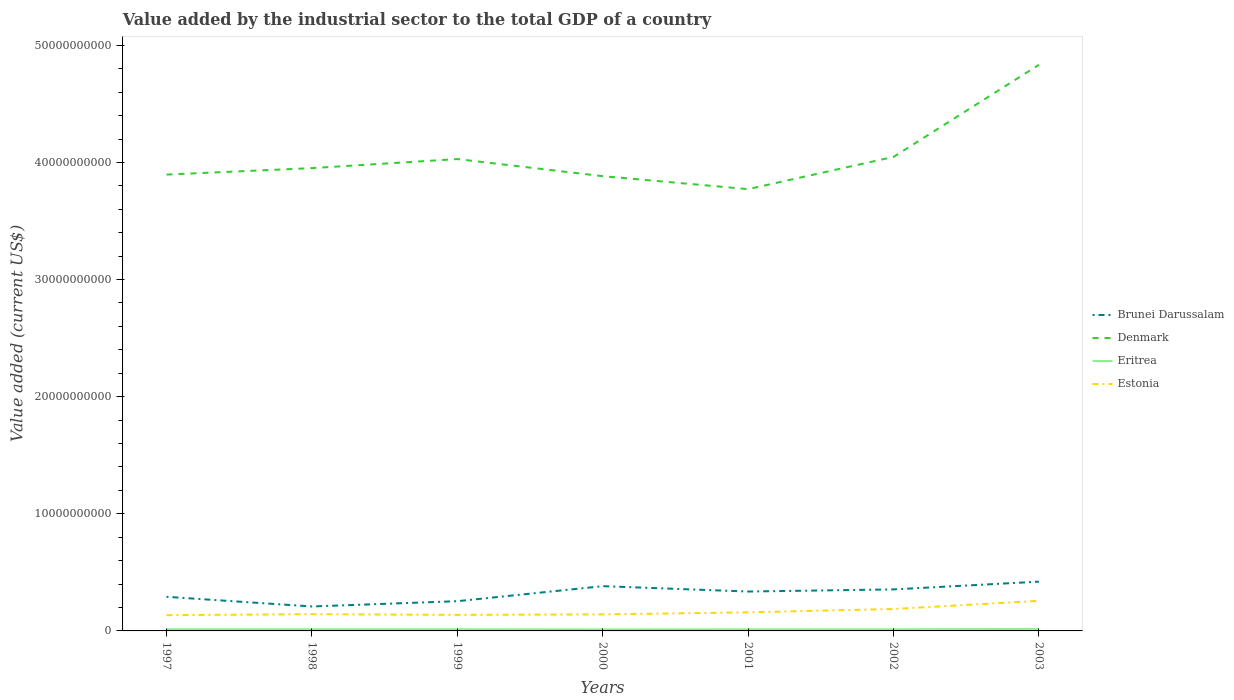Does the line corresponding to Eritrea intersect with the line corresponding to Denmark?
Ensure brevity in your answer.  No. Across all years, what is the maximum value added by the industrial sector to the total GDP in Denmark?
Make the answer very short. 3.77e+1. What is the total value added by the industrial sector to the total GDP in Brunei Darussalam in the graph?
Offer a very short reply. -9.08e+08. What is the difference between the highest and the second highest value added by the industrial sector to the total GDP in Denmark?
Provide a short and direct response. 1.06e+1. What is the difference between the highest and the lowest value added by the industrial sector to the total GDP in Estonia?
Provide a succinct answer. 2. Does the graph contain any zero values?
Provide a succinct answer. No. How many legend labels are there?
Your response must be concise. 4. How are the legend labels stacked?
Your answer should be very brief. Vertical. What is the title of the graph?
Your answer should be very brief. Value added by the industrial sector to the total GDP of a country. Does "Gabon" appear as one of the legend labels in the graph?
Provide a short and direct response. No. What is the label or title of the X-axis?
Offer a terse response. Years. What is the label or title of the Y-axis?
Offer a terse response. Value added (current US$). What is the Value added (current US$) of Brunei Darussalam in 1997?
Make the answer very short. 2.91e+09. What is the Value added (current US$) in Denmark in 1997?
Give a very brief answer. 3.90e+1. What is the Value added (current US$) of Eritrea in 1997?
Your response must be concise. 1.44e+08. What is the Value added (current US$) of Estonia in 1997?
Keep it short and to the point. 1.34e+09. What is the Value added (current US$) in Brunei Darussalam in 1998?
Your answer should be compact. 2.09e+09. What is the Value added (current US$) of Denmark in 1998?
Offer a terse response. 3.95e+1. What is the Value added (current US$) in Eritrea in 1998?
Make the answer very short. 1.44e+08. What is the Value added (current US$) of Estonia in 1998?
Your response must be concise. 1.43e+09. What is the Value added (current US$) of Brunei Darussalam in 1999?
Ensure brevity in your answer.  2.54e+09. What is the Value added (current US$) of Denmark in 1999?
Offer a very short reply. 4.03e+1. What is the Value added (current US$) of Eritrea in 1999?
Keep it short and to the point. 1.44e+08. What is the Value added (current US$) in Estonia in 1999?
Provide a short and direct response. 1.37e+09. What is the Value added (current US$) in Brunei Darussalam in 2000?
Keep it short and to the point. 3.82e+09. What is the Value added (current US$) of Denmark in 2000?
Your answer should be compact. 3.88e+1. What is the Value added (current US$) of Eritrea in 2000?
Your answer should be compact. 1.35e+08. What is the Value added (current US$) in Estonia in 2000?
Make the answer very short. 1.41e+09. What is the Value added (current US$) in Brunei Darussalam in 2001?
Ensure brevity in your answer.  3.36e+09. What is the Value added (current US$) in Denmark in 2001?
Provide a succinct answer. 3.77e+1. What is the Value added (current US$) of Eritrea in 2001?
Provide a succinct answer. 1.39e+08. What is the Value added (current US$) of Estonia in 2001?
Make the answer very short. 1.59e+09. What is the Value added (current US$) in Brunei Darussalam in 2002?
Provide a short and direct response. 3.54e+09. What is the Value added (current US$) in Denmark in 2002?
Make the answer very short. 4.05e+1. What is the Value added (current US$) of Eritrea in 2002?
Offer a terse response. 1.40e+08. What is the Value added (current US$) in Estonia in 2002?
Give a very brief answer. 1.87e+09. What is the Value added (current US$) in Brunei Darussalam in 2003?
Provide a short and direct response. 4.21e+09. What is the Value added (current US$) in Denmark in 2003?
Your answer should be compact. 4.83e+1. What is the Value added (current US$) of Eritrea in 2003?
Make the answer very short. 1.71e+08. What is the Value added (current US$) in Estonia in 2003?
Provide a succinct answer. 2.57e+09. Across all years, what is the maximum Value added (current US$) in Brunei Darussalam?
Your answer should be very brief. 4.21e+09. Across all years, what is the maximum Value added (current US$) of Denmark?
Make the answer very short. 4.83e+1. Across all years, what is the maximum Value added (current US$) of Eritrea?
Make the answer very short. 1.71e+08. Across all years, what is the maximum Value added (current US$) in Estonia?
Your response must be concise. 2.57e+09. Across all years, what is the minimum Value added (current US$) of Brunei Darussalam?
Give a very brief answer. 2.09e+09. Across all years, what is the minimum Value added (current US$) in Denmark?
Provide a succinct answer. 3.77e+1. Across all years, what is the minimum Value added (current US$) of Eritrea?
Make the answer very short. 1.35e+08. Across all years, what is the minimum Value added (current US$) of Estonia?
Provide a short and direct response. 1.34e+09. What is the total Value added (current US$) in Brunei Darussalam in the graph?
Give a very brief answer. 2.25e+1. What is the total Value added (current US$) in Denmark in the graph?
Ensure brevity in your answer.  2.84e+11. What is the total Value added (current US$) of Eritrea in the graph?
Give a very brief answer. 1.02e+09. What is the total Value added (current US$) in Estonia in the graph?
Provide a short and direct response. 1.16e+1. What is the difference between the Value added (current US$) of Brunei Darussalam in 1997 and that in 1998?
Give a very brief answer. 8.25e+08. What is the difference between the Value added (current US$) of Denmark in 1997 and that in 1998?
Keep it short and to the point. -5.51e+08. What is the difference between the Value added (current US$) of Eritrea in 1997 and that in 1998?
Your response must be concise. 2.91e+05. What is the difference between the Value added (current US$) of Estonia in 1997 and that in 1998?
Provide a succinct answer. -8.52e+07. What is the difference between the Value added (current US$) of Brunei Darussalam in 1997 and that in 1999?
Ensure brevity in your answer.  3.74e+08. What is the difference between the Value added (current US$) in Denmark in 1997 and that in 1999?
Keep it short and to the point. -1.32e+09. What is the difference between the Value added (current US$) of Eritrea in 1997 and that in 1999?
Make the answer very short. 2.24e+05. What is the difference between the Value added (current US$) of Estonia in 1997 and that in 1999?
Keep it short and to the point. -2.50e+07. What is the difference between the Value added (current US$) in Brunei Darussalam in 1997 and that in 2000?
Offer a very short reply. -9.08e+08. What is the difference between the Value added (current US$) in Denmark in 1997 and that in 2000?
Your answer should be very brief. 1.36e+08. What is the difference between the Value added (current US$) in Eritrea in 1997 and that in 2000?
Give a very brief answer. 8.69e+06. What is the difference between the Value added (current US$) of Estonia in 1997 and that in 2000?
Ensure brevity in your answer.  -6.87e+07. What is the difference between the Value added (current US$) in Brunei Darussalam in 1997 and that in 2001?
Your answer should be very brief. -4.50e+08. What is the difference between the Value added (current US$) of Denmark in 1997 and that in 2001?
Your response must be concise. 1.24e+09. What is the difference between the Value added (current US$) of Eritrea in 1997 and that in 2001?
Make the answer very short. 4.59e+06. What is the difference between the Value added (current US$) of Estonia in 1997 and that in 2001?
Make the answer very short. -2.42e+08. What is the difference between the Value added (current US$) of Brunei Darussalam in 1997 and that in 2002?
Your response must be concise. -6.32e+08. What is the difference between the Value added (current US$) of Denmark in 1997 and that in 2002?
Ensure brevity in your answer.  -1.51e+09. What is the difference between the Value added (current US$) of Eritrea in 1997 and that in 2002?
Your answer should be compact. 4.19e+06. What is the difference between the Value added (current US$) of Estonia in 1997 and that in 2002?
Your response must be concise. -5.27e+08. What is the difference between the Value added (current US$) in Brunei Darussalam in 1997 and that in 2003?
Keep it short and to the point. -1.29e+09. What is the difference between the Value added (current US$) in Denmark in 1997 and that in 2003?
Provide a succinct answer. -9.37e+09. What is the difference between the Value added (current US$) in Eritrea in 1997 and that in 2003?
Keep it short and to the point. -2.74e+07. What is the difference between the Value added (current US$) of Estonia in 1997 and that in 2003?
Offer a very short reply. -1.23e+09. What is the difference between the Value added (current US$) of Brunei Darussalam in 1998 and that in 1999?
Your answer should be compact. -4.51e+08. What is the difference between the Value added (current US$) in Denmark in 1998 and that in 1999?
Your answer should be compact. -7.73e+08. What is the difference between the Value added (current US$) of Eritrea in 1998 and that in 1999?
Make the answer very short. -6.68e+04. What is the difference between the Value added (current US$) in Estonia in 1998 and that in 1999?
Provide a short and direct response. 6.02e+07. What is the difference between the Value added (current US$) in Brunei Darussalam in 1998 and that in 2000?
Provide a succinct answer. -1.73e+09. What is the difference between the Value added (current US$) of Denmark in 1998 and that in 2000?
Offer a very short reply. 6.87e+08. What is the difference between the Value added (current US$) in Eritrea in 1998 and that in 2000?
Make the answer very short. 8.39e+06. What is the difference between the Value added (current US$) of Estonia in 1998 and that in 2000?
Your response must be concise. 1.65e+07. What is the difference between the Value added (current US$) of Brunei Darussalam in 1998 and that in 2001?
Your response must be concise. -1.28e+09. What is the difference between the Value added (current US$) in Denmark in 1998 and that in 2001?
Your response must be concise. 1.79e+09. What is the difference between the Value added (current US$) of Eritrea in 1998 and that in 2001?
Your response must be concise. 4.30e+06. What is the difference between the Value added (current US$) in Estonia in 1998 and that in 2001?
Keep it short and to the point. -1.57e+08. What is the difference between the Value added (current US$) in Brunei Darussalam in 1998 and that in 2002?
Offer a terse response. -1.46e+09. What is the difference between the Value added (current US$) in Denmark in 1998 and that in 2002?
Your answer should be compact. -9.56e+08. What is the difference between the Value added (current US$) in Eritrea in 1998 and that in 2002?
Offer a very short reply. 3.90e+06. What is the difference between the Value added (current US$) of Estonia in 1998 and that in 2002?
Provide a short and direct response. -4.42e+08. What is the difference between the Value added (current US$) of Brunei Darussalam in 1998 and that in 2003?
Provide a short and direct response. -2.12e+09. What is the difference between the Value added (current US$) in Denmark in 1998 and that in 2003?
Keep it short and to the point. -8.82e+09. What is the difference between the Value added (current US$) of Eritrea in 1998 and that in 2003?
Offer a terse response. -2.77e+07. What is the difference between the Value added (current US$) of Estonia in 1998 and that in 2003?
Provide a succinct answer. -1.14e+09. What is the difference between the Value added (current US$) in Brunei Darussalam in 1999 and that in 2000?
Ensure brevity in your answer.  -1.28e+09. What is the difference between the Value added (current US$) in Denmark in 1999 and that in 2000?
Provide a short and direct response. 1.46e+09. What is the difference between the Value added (current US$) in Eritrea in 1999 and that in 2000?
Offer a very short reply. 8.46e+06. What is the difference between the Value added (current US$) of Estonia in 1999 and that in 2000?
Make the answer very short. -4.37e+07. What is the difference between the Value added (current US$) of Brunei Darussalam in 1999 and that in 2001?
Provide a short and direct response. -8.25e+08. What is the difference between the Value added (current US$) in Denmark in 1999 and that in 2001?
Your answer should be compact. 2.57e+09. What is the difference between the Value added (current US$) in Eritrea in 1999 and that in 2001?
Give a very brief answer. 4.37e+06. What is the difference between the Value added (current US$) of Estonia in 1999 and that in 2001?
Give a very brief answer. -2.17e+08. What is the difference between the Value added (current US$) of Brunei Darussalam in 1999 and that in 2002?
Give a very brief answer. -1.01e+09. What is the difference between the Value added (current US$) in Denmark in 1999 and that in 2002?
Your answer should be very brief. -1.83e+08. What is the difference between the Value added (current US$) of Eritrea in 1999 and that in 2002?
Offer a terse response. 3.97e+06. What is the difference between the Value added (current US$) in Estonia in 1999 and that in 2002?
Offer a terse response. -5.02e+08. What is the difference between the Value added (current US$) of Brunei Darussalam in 1999 and that in 2003?
Offer a very short reply. -1.67e+09. What is the difference between the Value added (current US$) in Denmark in 1999 and that in 2003?
Keep it short and to the point. -8.05e+09. What is the difference between the Value added (current US$) in Eritrea in 1999 and that in 2003?
Your answer should be compact. -2.76e+07. What is the difference between the Value added (current US$) of Estonia in 1999 and that in 2003?
Provide a succinct answer. -1.20e+09. What is the difference between the Value added (current US$) of Brunei Darussalam in 2000 and that in 2001?
Make the answer very short. 4.58e+08. What is the difference between the Value added (current US$) of Denmark in 2000 and that in 2001?
Your answer should be very brief. 1.11e+09. What is the difference between the Value added (current US$) in Eritrea in 2000 and that in 2001?
Your answer should be very brief. -4.09e+06. What is the difference between the Value added (current US$) in Estonia in 2000 and that in 2001?
Make the answer very short. -1.74e+08. What is the difference between the Value added (current US$) in Brunei Darussalam in 2000 and that in 2002?
Your answer should be compact. 2.76e+08. What is the difference between the Value added (current US$) in Denmark in 2000 and that in 2002?
Offer a terse response. -1.64e+09. What is the difference between the Value added (current US$) in Eritrea in 2000 and that in 2002?
Your response must be concise. -4.49e+06. What is the difference between the Value added (current US$) in Estonia in 2000 and that in 2002?
Keep it short and to the point. -4.59e+08. What is the difference between the Value added (current US$) in Brunei Darussalam in 2000 and that in 2003?
Offer a terse response. -3.85e+08. What is the difference between the Value added (current US$) of Denmark in 2000 and that in 2003?
Ensure brevity in your answer.  -9.51e+09. What is the difference between the Value added (current US$) in Eritrea in 2000 and that in 2003?
Your answer should be very brief. -3.61e+07. What is the difference between the Value added (current US$) of Estonia in 2000 and that in 2003?
Offer a terse response. -1.16e+09. What is the difference between the Value added (current US$) in Brunei Darussalam in 2001 and that in 2002?
Your response must be concise. -1.82e+08. What is the difference between the Value added (current US$) in Denmark in 2001 and that in 2002?
Make the answer very short. -2.75e+09. What is the difference between the Value added (current US$) in Eritrea in 2001 and that in 2002?
Offer a terse response. -3.99e+05. What is the difference between the Value added (current US$) of Estonia in 2001 and that in 2002?
Keep it short and to the point. -2.85e+08. What is the difference between the Value added (current US$) in Brunei Darussalam in 2001 and that in 2003?
Keep it short and to the point. -8.43e+08. What is the difference between the Value added (current US$) in Denmark in 2001 and that in 2003?
Give a very brief answer. -1.06e+1. What is the difference between the Value added (current US$) in Eritrea in 2001 and that in 2003?
Your answer should be very brief. -3.20e+07. What is the difference between the Value added (current US$) in Estonia in 2001 and that in 2003?
Your answer should be very brief. -9.84e+08. What is the difference between the Value added (current US$) of Brunei Darussalam in 2002 and that in 2003?
Provide a succinct answer. -6.62e+08. What is the difference between the Value added (current US$) of Denmark in 2002 and that in 2003?
Keep it short and to the point. -7.87e+09. What is the difference between the Value added (current US$) in Eritrea in 2002 and that in 2003?
Your response must be concise. -3.16e+07. What is the difference between the Value added (current US$) in Estonia in 2002 and that in 2003?
Make the answer very short. -6.99e+08. What is the difference between the Value added (current US$) of Brunei Darussalam in 1997 and the Value added (current US$) of Denmark in 1998?
Give a very brief answer. -3.66e+1. What is the difference between the Value added (current US$) of Brunei Darussalam in 1997 and the Value added (current US$) of Eritrea in 1998?
Offer a terse response. 2.77e+09. What is the difference between the Value added (current US$) of Brunei Darussalam in 1997 and the Value added (current US$) of Estonia in 1998?
Offer a terse response. 1.48e+09. What is the difference between the Value added (current US$) in Denmark in 1997 and the Value added (current US$) in Eritrea in 1998?
Provide a short and direct response. 3.88e+1. What is the difference between the Value added (current US$) in Denmark in 1997 and the Value added (current US$) in Estonia in 1998?
Ensure brevity in your answer.  3.75e+1. What is the difference between the Value added (current US$) in Eritrea in 1997 and the Value added (current US$) in Estonia in 1998?
Offer a terse response. -1.28e+09. What is the difference between the Value added (current US$) in Brunei Darussalam in 1997 and the Value added (current US$) in Denmark in 1999?
Ensure brevity in your answer.  -3.74e+1. What is the difference between the Value added (current US$) of Brunei Darussalam in 1997 and the Value added (current US$) of Eritrea in 1999?
Ensure brevity in your answer.  2.77e+09. What is the difference between the Value added (current US$) in Brunei Darussalam in 1997 and the Value added (current US$) in Estonia in 1999?
Provide a succinct answer. 1.54e+09. What is the difference between the Value added (current US$) of Denmark in 1997 and the Value added (current US$) of Eritrea in 1999?
Ensure brevity in your answer.  3.88e+1. What is the difference between the Value added (current US$) of Denmark in 1997 and the Value added (current US$) of Estonia in 1999?
Offer a very short reply. 3.76e+1. What is the difference between the Value added (current US$) in Eritrea in 1997 and the Value added (current US$) in Estonia in 1999?
Offer a terse response. -1.22e+09. What is the difference between the Value added (current US$) of Brunei Darussalam in 1997 and the Value added (current US$) of Denmark in 2000?
Provide a short and direct response. -3.59e+1. What is the difference between the Value added (current US$) in Brunei Darussalam in 1997 and the Value added (current US$) in Eritrea in 2000?
Your answer should be compact. 2.78e+09. What is the difference between the Value added (current US$) of Brunei Darussalam in 1997 and the Value added (current US$) of Estonia in 2000?
Offer a terse response. 1.50e+09. What is the difference between the Value added (current US$) of Denmark in 1997 and the Value added (current US$) of Eritrea in 2000?
Make the answer very short. 3.88e+1. What is the difference between the Value added (current US$) in Denmark in 1997 and the Value added (current US$) in Estonia in 2000?
Keep it short and to the point. 3.76e+1. What is the difference between the Value added (current US$) of Eritrea in 1997 and the Value added (current US$) of Estonia in 2000?
Provide a succinct answer. -1.27e+09. What is the difference between the Value added (current US$) in Brunei Darussalam in 1997 and the Value added (current US$) in Denmark in 2001?
Your response must be concise. -3.48e+1. What is the difference between the Value added (current US$) of Brunei Darussalam in 1997 and the Value added (current US$) of Eritrea in 2001?
Offer a terse response. 2.77e+09. What is the difference between the Value added (current US$) of Brunei Darussalam in 1997 and the Value added (current US$) of Estonia in 2001?
Your response must be concise. 1.33e+09. What is the difference between the Value added (current US$) in Denmark in 1997 and the Value added (current US$) in Eritrea in 2001?
Your answer should be compact. 3.88e+1. What is the difference between the Value added (current US$) in Denmark in 1997 and the Value added (current US$) in Estonia in 2001?
Give a very brief answer. 3.74e+1. What is the difference between the Value added (current US$) of Eritrea in 1997 and the Value added (current US$) of Estonia in 2001?
Offer a terse response. -1.44e+09. What is the difference between the Value added (current US$) in Brunei Darussalam in 1997 and the Value added (current US$) in Denmark in 2002?
Your response must be concise. -3.76e+1. What is the difference between the Value added (current US$) in Brunei Darussalam in 1997 and the Value added (current US$) in Eritrea in 2002?
Your answer should be very brief. 2.77e+09. What is the difference between the Value added (current US$) of Brunei Darussalam in 1997 and the Value added (current US$) of Estonia in 2002?
Offer a terse response. 1.04e+09. What is the difference between the Value added (current US$) in Denmark in 1997 and the Value added (current US$) in Eritrea in 2002?
Offer a very short reply. 3.88e+1. What is the difference between the Value added (current US$) of Denmark in 1997 and the Value added (current US$) of Estonia in 2002?
Your answer should be compact. 3.71e+1. What is the difference between the Value added (current US$) of Eritrea in 1997 and the Value added (current US$) of Estonia in 2002?
Your answer should be very brief. -1.73e+09. What is the difference between the Value added (current US$) of Brunei Darussalam in 1997 and the Value added (current US$) of Denmark in 2003?
Offer a terse response. -4.54e+1. What is the difference between the Value added (current US$) in Brunei Darussalam in 1997 and the Value added (current US$) in Eritrea in 2003?
Give a very brief answer. 2.74e+09. What is the difference between the Value added (current US$) of Brunei Darussalam in 1997 and the Value added (current US$) of Estonia in 2003?
Offer a very short reply. 3.43e+08. What is the difference between the Value added (current US$) in Denmark in 1997 and the Value added (current US$) in Eritrea in 2003?
Provide a succinct answer. 3.88e+1. What is the difference between the Value added (current US$) of Denmark in 1997 and the Value added (current US$) of Estonia in 2003?
Give a very brief answer. 3.64e+1. What is the difference between the Value added (current US$) of Eritrea in 1997 and the Value added (current US$) of Estonia in 2003?
Ensure brevity in your answer.  -2.43e+09. What is the difference between the Value added (current US$) in Brunei Darussalam in 1998 and the Value added (current US$) in Denmark in 1999?
Offer a very short reply. -3.82e+1. What is the difference between the Value added (current US$) of Brunei Darussalam in 1998 and the Value added (current US$) of Eritrea in 1999?
Your answer should be very brief. 1.94e+09. What is the difference between the Value added (current US$) of Brunei Darussalam in 1998 and the Value added (current US$) of Estonia in 1999?
Keep it short and to the point. 7.19e+08. What is the difference between the Value added (current US$) of Denmark in 1998 and the Value added (current US$) of Eritrea in 1999?
Give a very brief answer. 3.94e+1. What is the difference between the Value added (current US$) of Denmark in 1998 and the Value added (current US$) of Estonia in 1999?
Make the answer very short. 3.81e+1. What is the difference between the Value added (current US$) of Eritrea in 1998 and the Value added (current US$) of Estonia in 1999?
Provide a succinct answer. -1.22e+09. What is the difference between the Value added (current US$) of Brunei Darussalam in 1998 and the Value added (current US$) of Denmark in 2000?
Provide a succinct answer. -3.67e+1. What is the difference between the Value added (current US$) in Brunei Darussalam in 1998 and the Value added (current US$) in Eritrea in 2000?
Your answer should be compact. 1.95e+09. What is the difference between the Value added (current US$) in Brunei Darussalam in 1998 and the Value added (current US$) in Estonia in 2000?
Ensure brevity in your answer.  6.75e+08. What is the difference between the Value added (current US$) in Denmark in 1998 and the Value added (current US$) in Eritrea in 2000?
Provide a succinct answer. 3.94e+1. What is the difference between the Value added (current US$) in Denmark in 1998 and the Value added (current US$) in Estonia in 2000?
Keep it short and to the point. 3.81e+1. What is the difference between the Value added (current US$) in Eritrea in 1998 and the Value added (current US$) in Estonia in 2000?
Ensure brevity in your answer.  -1.27e+09. What is the difference between the Value added (current US$) in Brunei Darussalam in 1998 and the Value added (current US$) in Denmark in 2001?
Your answer should be very brief. -3.56e+1. What is the difference between the Value added (current US$) of Brunei Darussalam in 1998 and the Value added (current US$) of Eritrea in 2001?
Keep it short and to the point. 1.95e+09. What is the difference between the Value added (current US$) of Brunei Darussalam in 1998 and the Value added (current US$) of Estonia in 2001?
Offer a terse response. 5.02e+08. What is the difference between the Value added (current US$) of Denmark in 1998 and the Value added (current US$) of Eritrea in 2001?
Offer a terse response. 3.94e+1. What is the difference between the Value added (current US$) of Denmark in 1998 and the Value added (current US$) of Estonia in 2001?
Offer a very short reply. 3.79e+1. What is the difference between the Value added (current US$) in Eritrea in 1998 and the Value added (current US$) in Estonia in 2001?
Make the answer very short. -1.44e+09. What is the difference between the Value added (current US$) in Brunei Darussalam in 1998 and the Value added (current US$) in Denmark in 2002?
Keep it short and to the point. -3.84e+1. What is the difference between the Value added (current US$) in Brunei Darussalam in 1998 and the Value added (current US$) in Eritrea in 2002?
Give a very brief answer. 1.95e+09. What is the difference between the Value added (current US$) of Brunei Darussalam in 1998 and the Value added (current US$) of Estonia in 2002?
Give a very brief answer. 2.17e+08. What is the difference between the Value added (current US$) of Denmark in 1998 and the Value added (current US$) of Eritrea in 2002?
Give a very brief answer. 3.94e+1. What is the difference between the Value added (current US$) of Denmark in 1998 and the Value added (current US$) of Estonia in 2002?
Give a very brief answer. 3.76e+1. What is the difference between the Value added (current US$) in Eritrea in 1998 and the Value added (current US$) in Estonia in 2002?
Make the answer very short. -1.73e+09. What is the difference between the Value added (current US$) in Brunei Darussalam in 1998 and the Value added (current US$) in Denmark in 2003?
Give a very brief answer. -4.62e+1. What is the difference between the Value added (current US$) of Brunei Darussalam in 1998 and the Value added (current US$) of Eritrea in 2003?
Your answer should be very brief. 1.92e+09. What is the difference between the Value added (current US$) in Brunei Darussalam in 1998 and the Value added (current US$) in Estonia in 2003?
Your answer should be compact. -4.82e+08. What is the difference between the Value added (current US$) in Denmark in 1998 and the Value added (current US$) in Eritrea in 2003?
Give a very brief answer. 3.93e+1. What is the difference between the Value added (current US$) of Denmark in 1998 and the Value added (current US$) of Estonia in 2003?
Your answer should be compact. 3.69e+1. What is the difference between the Value added (current US$) in Eritrea in 1998 and the Value added (current US$) in Estonia in 2003?
Your answer should be very brief. -2.43e+09. What is the difference between the Value added (current US$) in Brunei Darussalam in 1999 and the Value added (current US$) in Denmark in 2000?
Provide a succinct answer. -3.63e+1. What is the difference between the Value added (current US$) in Brunei Darussalam in 1999 and the Value added (current US$) in Eritrea in 2000?
Your answer should be very brief. 2.40e+09. What is the difference between the Value added (current US$) of Brunei Darussalam in 1999 and the Value added (current US$) of Estonia in 2000?
Offer a terse response. 1.13e+09. What is the difference between the Value added (current US$) of Denmark in 1999 and the Value added (current US$) of Eritrea in 2000?
Give a very brief answer. 4.02e+1. What is the difference between the Value added (current US$) in Denmark in 1999 and the Value added (current US$) in Estonia in 2000?
Your answer should be very brief. 3.89e+1. What is the difference between the Value added (current US$) of Eritrea in 1999 and the Value added (current US$) of Estonia in 2000?
Ensure brevity in your answer.  -1.27e+09. What is the difference between the Value added (current US$) of Brunei Darussalam in 1999 and the Value added (current US$) of Denmark in 2001?
Provide a short and direct response. -3.52e+1. What is the difference between the Value added (current US$) of Brunei Darussalam in 1999 and the Value added (current US$) of Eritrea in 2001?
Your answer should be very brief. 2.40e+09. What is the difference between the Value added (current US$) in Brunei Darussalam in 1999 and the Value added (current US$) in Estonia in 2001?
Offer a terse response. 9.53e+08. What is the difference between the Value added (current US$) in Denmark in 1999 and the Value added (current US$) in Eritrea in 2001?
Your answer should be very brief. 4.01e+1. What is the difference between the Value added (current US$) of Denmark in 1999 and the Value added (current US$) of Estonia in 2001?
Offer a terse response. 3.87e+1. What is the difference between the Value added (current US$) in Eritrea in 1999 and the Value added (current US$) in Estonia in 2001?
Your answer should be compact. -1.44e+09. What is the difference between the Value added (current US$) of Brunei Darussalam in 1999 and the Value added (current US$) of Denmark in 2002?
Your answer should be very brief. -3.79e+1. What is the difference between the Value added (current US$) in Brunei Darussalam in 1999 and the Value added (current US$) in Eritrea in 2002?
Offer a very short reply. 2.40e+09. What is the difference between the Value added (current US$) of Brunei Darussalam in 1999 and the Value added (current US$) of Estonia in 2002?
Make the answer very short. 6.67e+08. What is the difference between the Value added (current US$) of Denmark in 1999 and the Value added (current US$) of Eritrea in 2002?
Your answer should be compact. 4.01e+1. What is the difference between the Value added (current US$) in Denmark in 1999 and the Value added (current US$) in Estonia in 2002?
Offer a terse response. 3.84e+1. What is the difference between the Value added (current US$) in Eritrea in 1999 and the Value added (current US$) in Estonia in 2002?
Provide a succinct answer. -1.73e+09. What is the difference between the Value added (current US$) in Brunei Darussalam in 1999 and the Value added (current US$) in Denmark in 2003?
Offer a very short reply. -4.58e+1. What is the difference between the Value added (current US$) of Brunei Darussalam in 1999 and the Value added (current US$) of Eritrea in 2003?
Keep it short and to the point. 2.37e+09. What is the difference between the Value added (current US$) in Brunei Darussalam in 1999 and the Value added (current US$) in Estonia in 2003?
Offer a very short reply. -3.13e+07. What is the difference between the Value added (current US$) of Denmark in 1999 and the Value added (current US$) of Eritrea in 2003?
Make the answer very short. 4.01e+1. What is the difference between the Value added (current US$) in Denmark in 1999 and the Value added (current US$) in Estonia in 2003?
Your response must be concise. 3.77e+1. What is the difference between the Value added (current US$) of Eritrea in 1999 and the Value added (current US$) of Estonia in 2003?
Offer a terse response. -2.43e+09. What is the difference between the Value added (current US$) of Brunei Darussalam in 2000 and the Value added (current US$) of Denmark in 2001?
Your response must be concise. -3.39e+1. What is the difference between the Value added (current US$) in Brunei Darussalam in 2000 and the Value added (current US$) in Eritrea in 2001?
Give a very brief answer. 3.68e+09. What is the difference between the Value added (current US$) in Brunei Darussalam in 2000 and the Value added (current US$) in Estonia in 2001?
Give a very brief answer. 2.24e+09. What is the difference between the Value added (current US$) of Denmark in 2000 and the Value added (current US$) of Eritrea in 2001?
Your answer should be very brief. 3.87e+1. What is the difference between the Value added (current US$) in Denmark in 2000 and the Value added (current US$) in Estonia in 2001?
Offer a terse response. 3.72e+1. What is the difference between the Value added (current US$) in Eritrea in 2000 and the Value added (current US$) in Estonia in 2001?
Provide a succinct answer. -1.45e+09. What is the difference between the Value added (current US$) in Brunei Darussalam in 2000 and the Value added (current US$) in Denmark in 2002?
Make the answer very short. -3.67e+1. What is the difference between the Value added (current US$) of Brunei Darussalam in 2000 and the Value added (current US$) of Eritrea in 2002?
Offer a terse response. 3.68e+09. What is the difference between the Value added (current US$) of Brunei Darussalam in 2000 and the Value added (current US$) of Estonia in 2002?
Your answer should be compact. 1.95e+09. What is the difference between the Value added (current US$) in Denmark in 2000 and the Value added (current US$) in Eritrea in 2002?
Your answer should be compact. 3.87e+1. What is the difference between the Value added (current US$) in Denmark in 2000 and the Value added (current US$) in Estonia in 2002?
Ensure brevity in your answer.  3.70e+1. What is the difference between the Value added (current US$) of Eritrea in 2000 and the Value added (current US$) of Estonia in 2002?
Offer a terse response. -1.74e+09. What is the difference between the Value added (current US$) in Brunei Darussalam in 2000 and the Value added (current US$) in Denmark in 2003?
Provide a succinct answer. -4.45e+1. What is the difference between the Value added (current US$) in Brunei Darussalam in 2000 and the Value added (current US$) in Eritrea in 2003?
Give a very brief answer. 3.65e+09. What is the difference between the Value added (current US$) in Brunei Darussalam in 2000 and the Value added (current US$) in Estonia in 2003?
Your answer should be compact. 1.25e+09. What is the difference between the Value added (current US$) in Denmark in 2000 and the Value added (current US$) in Eritrea in 2003?
Provide a succinct answer. 3.87e+1. What is the difference between the Value added (current US$) of Denmark in 2000 and the Value added (current US$) of Estonia in 2003?
Provide a succinct answer. 3.63e+1. What is the difference between the Value added (current US$) in Eritrea in 2000 and the Value added (current US$) in Estonia in 2003?
Offer a very short reply. -2.43e+09. What is the difference between the Value added (current US$) in Brunei Darussalam in 2001 and the Value added (current US$) in Denmark in 2002?
Give a very brief answer. -3.71e+1. What is the difference between the Value added (current US$) in Brunei Darussalam in 2001 and the Value added (current US$) in Eritrea in 2002?
Ensure brevity in your answer.  3.22e+09. What is the difference between the Value added (current US$) of Brunei Darussalam in 2001 and the Value added (current US$) of Estonia in 2002?
Provide a succinct answer. 1.49e+09. What is the difference between the Value added (current US$) in Denmark in 2001 and the Value added (current US$) in Eritrea in 2002?
Offer a terse response. 3.76e+1. What is the difference between the Value added (current US$) in Denmark in 2001 and the Value added (current US$) in Estonia in 2002?
Your answer should be very brief. 3.59e+1. What is the difference between the Value added (current US$) in Eritrea in 2001 and the Value added (current US$) in Estonia in 2002?
Your response must be concise. -1.73e+09. What is the difference between the Value added (current US$) in Brunei Darussalam in 2001 and the Value added (current US$) in Denmark in 2003?
Provide a short and direct response. -4.50e+1. What is the difference between the Value added (current US$) in Brunei Darussalam in 2001 and the Value added (current US$) in Eritrea in 2003?
Offer a very short reply. 3.19e+09. What is the difference between the Value added (current US$) in Brunei Darussalam in 2001 and the Value added (current US$) in Estonia in 2003?
Your response must be concise. 7.93e+08. What is the difference between the Value added (current US$) of Denmark in 2001 and the Value added (current US$) of Eritrea in 2003?
Provide a succinct answer. 3.76e+1. What is the difference between the Value added (current US$) in Denmark in 2001 and the Value added (current US$) in Estonia in 2003?
Ensure brevity in your answer.  3.52e+1. What is the difference between the Value added (current US$) of Eritrea in 2001 and the Value added (current US$) of Estonia in 2003?
Give a very brief answer. -2.43e+09. What is the difference between the Value added (current US$) of Brunei Darussalam in 2002 and the Value added (current US$) of Denmark in 2003?
Provide a short and direct response. -4.48e+1. What is the difference between the Value added (current US$) in Brunei Darussalam in 2002 and the Value added (current US$) in Eritrea in 2003?
Your answer should be very brief. 3.37e+09. What is the difference between the Value added (current US$) in Brunei Darussalam in 2002 and the Value added (current US$) in Estonia in 2003?
Provide a succinct answer. 9.75e+08. What is the difference between the Value added (current US$) in Denmark in 2002 and the Value added (current US$) in Eritrea in 2003?
Your answer should be compact. 4.03e+1. What is the difference between the Value added (current US$) of Denmark in 2002 and the Value added (current US$) of Estonia in 2003?
Give a very brief answer. 3.79e+1. What is the difference between the Value added (current US$) of Eritrea in 2002 and the Value added (current US$) of Estonia in 2003?
Provide a short and direct response. -2.43e+09. What is the average Value added (current US$) in Brunei Darussalam per year?
Keep it short and to the point. 3.21e+09. What is the average Value added (current US$) in Denmark per year?
Make the answer very short. 4.06e+1. What is the average Value added (current US$) in Eritrea per year?
Your response must be concise. 1.45e+08. What is the average Value added (current US$) of Estonia per year?
Your answer should be very brief. 1.65e+09. In the year 1997, what is the difference between the Value added (current US$) of Brunei Darussalam and Value added (current US$) of Denmark?
Your answer should be very brief. -3.61e+1. In the year 1997, what is the difference between the Value added (current US$) in Brunei Darussalam and Value added (current US$) in Eritrea?
Your response must be concise. 2.77e+09. In the year 1997, what is the difference between the Value added (current US$) of Brunei Darussalam and Value added (current US$) of Estonia?
Offer a very short reply. 1.57e+09. In the year 1997, what is the difference between the Value added (current US$) of Denmark and Value added (current US$) of Eritrea?
Ensure brevity in your answer.  3.88e+1. In the year 1997, what is the difference between the Value added (current US$) in Denmark and Value added (current US$) in Estonia?
Provide a succinct answer. 3.76e+1. In the year 1997, what is the difference between the Value added (current US$) of Eritrea and Value added (current US$) of Estonia?
Your answer should be compact. -1.20e+09. In the year 1998, what is the difference between the Value added (current US$) of Brunei Darussalam and Value added (current US$) of Denmark?
Your answer should be very brief. -3.74e+1. In the year 1998, what is the difference between the Value added (current US$) of Brunei Darussalam and Value added (current US$) of Eritrea?
Offer a terse response. 1.94e+09. In the year 1998, what is the difference between the Value added (current US$) of Brunei Darussalam and Value added (current US$) of Estonia?
Provide a short and direct response. 6.59e+08. In the year 1998, what is the difference between the Value added (current US$) of Denmark and Value added (current US$) of Eritrea?
Your response must be concise. 3.94e+1. In the year 1998, what is the difference between the Value added (current US$) in Denmark and Value added (current US$) in Estonia?
Offer a terse response. 3.81e+1. In the year 1998, what is the difference between the Value added (current US$) of Eritrea and Value added (current US$) of Estonia?
Offer a terse response. -1.29e+09. In the year 1999, what is the difference between the Value added (current US$) in Brunei Darussalam and Value added (current US$) in Denmark?
Provide a succinct answer. -3.77e+1. In the year 1999, what is the difference between the Value added (current US$) in Brunei Darussalam and Value added (current US$) in Eritrea?
Provide a succinct answer. 2.39e+09. In the year 1999, what is the difference between the Value added (current US$) in Brunei Darussalam and Value added (current US$) in Estonia?
Your response must be concise. 1.17e+09. In the year 1999, what is the difference between the Value added (current US$) in Denmark and Value added (current US$) in Eritrea?
Your response must be concise. 4.01e+1. In the year 1999, what is the difference between the Value added (current US$) in Denmark and Value added (current US$) in Estonia?
Your answer should be compact. 3.89e+1. In the year 1999, what is the difference between the Value added (current US$) of Eritrea and Value added (current US$) of Estonia?
Your answer should be very brief. -1.22e+09. In the year 2000, what is the difference between the Value added (current US$) of Brunei Darussalam and Value added (current US$) of Denmark?
Provide a succinct answer. -3.50e+1. In the year 2000, what is the difference between the Value added (current US$) in Brunei Darussalam and Value added (current US$) in Eritrea?
Give a very brief answer. 3.69e+09. In the year 2000, what is the difference between the Value added (current US$) of Brunei Darussalam and Value added (current US$) of Estonia?
Your answer should be very brief. 2.41e+09. In the year 2000, what is the difference between the Value added (current US$) in Denmark and Value added (current US$) in Eritrea?
Your answer should be very brief. 3.87e+1. In the year 2000, what is the difference between the Value added (current US$) in Denmark and Value added (current US$) in Estonia?
Offer a very short reply. 3.74e+1. In the year 2000, what is the difference between the Value added (current US$) of Eritrea and Value added (current US$) of Estonia?
Provide a succinct answer. -1.28e+09. In the year 2001, what is the difference between the Value added (current US$) in Brunei Darussalam and Value added (current US$) in Denmark?
Make the answer very short. -3.44e+1. In the year 2001, what is the difference between the Value added (current US$) of Brunei Darussalam and Value added (current US$) of Eritrea?
Your response must be concise. 3.22e+09. In the year 2001, what is the difference between the Value added (current US$) in Brunei Darussalam and Value added (current US$) in Estonia?
Give a very brief answer. 1.78e+09. In the year 2001, what is the difference between the Value added (current US$) of Denmark and Value added (current US$) of Eritrea?
Ensure brevity in your answer.  3.76e+1. In the year 2001, what is the difference between the Value added (current US$) in Denmark and Value added (current US$) in Estonia?
Your answer should be very brief. 3.61e+1. In the year 2001, what is the difference between the Value added (current US$) of Eritrea and Value added (current US$) of Estonia?
Ensure brevity in your answer.  -1.45e+09. In the year 2002, what is the difference between the Value added (current US$) in Brunei Darussalam and Value added (current US$) in Denmark?
Your response must be concise. -3.69e+1. In the year 2002, what is the difference between the Value added (current US$) of Brunei Darussalam and Value added (current US$) of Eritrea?
Offer a very short reply. 3.40e+09. In the year 2002, what is the difference between the Value added (current US$) in Brunei Darussalam and Value added (current US$) in Estonia?
Keep it short and to the point. 1.67e+09. In the year 2002, what is the difference between the Value added (current US$) in Denmark and Value added (current US$) in Eritrea?
Make the answer very short. 4.03e+1. In the year 2002, what is the difference between the Value added (current US$) in Denmark and Value added (current US$) in Estonia?
Your answer should be compact. 3.86e+1. In the year 2002, what is the difference between the Value added (current US$) of Eritrea and Value added (current US$) of Estonia?
Ensure brevity in your answer.  -1.73e+09. In the year 2003, what is the difference between the Value added (current US$) of Brunei Darussalam and Value added (current US$) of Denmark?
Ensure brevity in your answer.  -4.41e+1. In the year 2003, what is the difference between the Value added (current US$) of Brunei Darussalam and Value added (current US$) of Eritrea?
Offer a terse response. 4.03e+09. In the year 2003, what is the difference between the Value added (current US$) of Brunei Darussalam and Value added (current US$) of Estonia?
Ensure brevity in your answer.  1.64e+09. In the year 2003, what is the difference between the Value added (current US$) in Denmark and Value added (current US$) in Eritrea?
Keep it short and to the point. 4.82e+1. In the year 2003, what is the difference between the Value added (current US$) of Denmark and Value added (current US$) of Estonia?
Provide a succinct answer. 4.58e+1. In the year 2003, what is the difference between the Value added (current US$) in Eritrea and Value added (current US$) in Estonia?
Your answer should be very brief. -2.40e+09. What is the ratio of the Value added (current US$) in Brunei Darussalam in 1997 to that in 1998?
Make the answer very short. 1.4. What is the ratio of the Value added (current US$) of Denmark in 1997 to that in 1998?
Give a very brief answer. 0.99. What is the ratio of the Value added (current US$) of Estonia in 1997 to that in 1998?
Provide a succinct answer. 0.94. What is the ratio of the Value added (current US$) in Brunei Darussalam in 1997 to that in 1999?
Offer a terse response. 1.15. What is the ratio of the Value added (current US$) of Denmark in 1997 to that in 1999?
Provide a succinct answer. 0.97. What is the ratio of the Value added (current US$) of Estonia in 1997 to that in 1999?
Give a very brief answer. 0.98. What is the ratio of the Value added (current US$) of Brunei Darussalam in 1997 to that in 2000?
Provide a succinct answer. 0.76. What is the ratio of the Value added (current US$) of Denmark in 1997 to that in 2000?
Ensure brevity in your answer.  1. What is the ratio of the Value added (current US$) in Eritrea in 1997 to that in 2000?
Provide a succinct answer. 1.06. What is the ratio of the Value added (current US$) in Estonia in 1997 to that in 2000?
Provide a succinct answer. 0.95. What is the ratio of the Value added (current US$) in Brunei Darussalam in 1997 to that in 2001?
Make the answer very short. 0.87. What is the ratio of the Value added (current US$) of Denmark in 1997 to that in 2001?
Provide a short and direct response. 1.03. What is the ratio of the Value added (current US$) in Eritrea in 1997 to that in 2001?
Ensure brevity in your answer.  1.03. What is the ratio of the Value added (current US$) in Estonia in 1997 to that in 2001?
Keep it short and to the point. 0.85. What is the ratio of the Value added (current US$) in Brunei Darussalam in 1997 to that in 2002?
Keep it short and to the point. 0.82. What is the ratio of the Value added (current US$) in Denmark in 1997 to that in 2002?
Offer a terse response. 0.96. What is the ratio of the Value added (current US$) of Estonia in 1997 to that in 2002?
Make the answer very short. 0.72. What is the ratio of the Value added (current US$) in Brunei Darussalam in 1997 to that in 2003?
Make the answer very short. 0.69. What is the ratio of the Value added (current US$) of Denmark in 1997 to that in 2003?
Offer a terse response. 0.81. What is the ratio of the Value added (current US$) of Eritrea in 1997 to that in 2003?
Keep it short and to the point. 0.84. What is the ratio of the Value added (current US$) in Estonia in 1997 to that in 2003?
Your answer should be compact. 0.52. What is the ratio of the Value added (current US$) in Brunei Darussalam in 1998 to that in 1999?
Your answer should be very brief. 0.82. What is the ratio of the Value added (current US$) in Denmark in 1998 to that in 1999?
Offer a very short reply. 0.98. What is the ratio of the Value added (current US$) of Eritrea in 1998 to that in 1999?
Give a very brief answer. 1. What is the ratio of the Value added (current US$) in Estonia in 1998 to that in 1999?
Your answer should be very brief. 1.04. What is the ratio of the Value added (current US$) of Brunei Darussalam in 1998 to that in 2000?
Provide a short and direct response. 0.55. What is the ratio of the Value added (current US$) in Denmark in 1998 to that in 2000?
Ensure brevity in your answer.  1.02. What is the ratio of the Value added (current US$) in Eritrea in 1998 to that in 2000?
Give a very brief answer. 1.06. What is the ratio of the Value added (current US$) of Estonia in 1998 to that in 2000?
Offer a terse response. 1.01. What is the ratio of the Value added (current US$) in Brunei Darussalam in 1998 to that in 2001?
Offer a terse response. 0.62. What is the ratio of the Value added (current US$) of Denmark in 1998 to that in 2001?
Your answer should be compact. 1.05. What is the ratio of the Value added (current US$) of Eritrea in 1998 to that in 2001?
Your answer should be compact. 1.03. What is the ratio of the Value added (current US$) in Estonia in 1998 to that in 2001?
Make the answer very short. 0.9. What is the ratio of the Value added (current US$) in Brunei Darussalam in 1998 to that in 2002?
Your answer should be very brief. 0.59. What is the ratio of the Value added (current US$) of Denmark in 1998 to that in 2002?
Ensure brevity in your answer.  0.98. What is the ratio of the Value added (current US$) of Eritrea in 1998 to that in 2002?
Make the answer very short. 1.03. What is the ratio of the Value added (current US$) in Estonia in 1998 to that in 2002?
Provide a succinct answer. 0.76. What is the ratio of the Value added (current US$) of Brunei Darussalam in 1998 to that in 2003?
Offer a very short reply. 0.5. What is the ratio of the Value added (current US$) in Denmark in 1998 to that in 2003?
Offer a terse response. 0.82. What is the ratio of the Value added (current US$) of Eritrea in 1998 to that in 2003?
Give a very brief answer. 0.84. What is the ratio of the Value added (current US$) of Estonia in 1998 to that in 2003?
Make the answer very short. 0.56. What is the ratio of the Value added (current US$) in Brunei Darussalam in 1999 to that in 2000?
Give a very brief answer. 0.66. What is the ratio of the Value added (current US$) of Denmark in 1999 to that in 2000?
Make the answer very short. 1.04. What is the ratio of the Value added (current US$) in Eritrea in 1999 to that in 2000?
Make the answer very short. 1.06. What is the ratio of the Value added (current US$) in Brunei Darussalam in 1999 to that in 2001?
Your answer should be compact. 0.75. What is the ratio of the Value added (current US$) of Denmark in 1999 to that in 2001?
Ensure brevity in your answer.  1.07. What is the ratio of the Value added (current US$) of Eritrea in 1999 to that in 2001?
Give a very brief answer. 1.03. What is the ratio of the Value added (current US$) of Estonia in 1999 to that in 2001?
Your answer should be compact. 0.86. What is the ratio of the Value added (current US$) in Brunei Darussalam in 1999 to that in 2002?
Your answer should be compact. 0.72. What is the ratio of the Value added (current US$) in Denmark in 1999 to that in 2002?
Keep it short and to the point. 1. What is the ratio of the Value added (current US$) of Eritrea in 1999 to that in 2002?
Give a very brief answer. 1.03. What is the ratio of the Value added (current US$) of Estonia in 1999 to that in 2002?
Provide a short and direct response. 0.73. What is the ratio of the Value added (current US$) of Brunei Darussalam in 1999 to that in 2003?
Ensure brevity in your answer.  0.6. What is the ratio of the Value added (current US$) of Denmark in 1999 to that in 2003?
Provide a short and direct response. 0.83. What is the ratio of the Value added (current US$) of Eritrea in 1999 to that in 2003?
Provide a succinct answer. 0.84. What is the ratio of the Value added (current US$) in Estonia in 1999 to that in 2003?
Make the answer very short. 0.53. What is the ratio of the Value added (current US$) of Brunei Darussalam in 2000 to that in 2001?
Offer a terse response. 1.14. What is the ratio of the Value added (current US$) of Denmark in 2000 to that in 2001?
Offer a terse response. 1.03. What is the ratio of the Value added (current US$) of Eritrea in 2000 to that in 2001?
Provide a short and direct response. 0.97. What is the ratio of the Value added (current US$) in Estonia in 2000 to that in 2001?
Offer a terse response. 0.89. What is the ratio of the Value added (current US$) of Brunei Darussalam in 2000 to that in 2002?
Give a very brief answer. 1.08. What is the ratio of the Value added (current US$) of Denmark in 2000 to that in 2002?
Offer a terse response. 0.96. What is the ratio of the Value added (current US$) in Eritrea in 2000 to that in 2002?
Your answer should be compact. 0.97. What is the ratio of the Value added (current US$) in Estonia in 2000 to that in 2002?
Provide a short and direct response. 0.75. What is the ratio of the Value added (current US$) of Brunei Darussalam in 2000 to that in 2003?
Offer a terse response. 0.91. What is the ratio of the Value added (current US$) of Denmark in 2000 to that in 2003?
Your answer should be very brief. 0.8. What is the ratio of the Value added (current US$) of Eritrea in 2000 to that in 2003?
Make the answer very short. 0.79. What is the ratio of the Value added (current US$) of Estonia in 2000 to that in 2003?
Offer a terse response. 0.55. What is the ratio of the Value added (current US$) in Brunei Darussalam in 2001 to that in 2002?
Offer a terse response. 0.95. What is the ratio of the Value added (current US$) in Denmark in 2001 to that in 2002?
Your answer should be very brief. 0.93. What is the ratio of the Value added (current US$) in Estonia in 2001 to that in 2002?
Provide a short and direct response. 0.85. What is the ratio of the Value added (current US$) of Brunei Darussalam in 2001 to that in 2003?
Your answer should be very brief. 0.8. What is the ratio of the Value added (current US$) in Denmark in 2001 to that in 2003?
Provide a short and direct response. 0.78. What is the ratio of the Value added (current US$) of Eritrea in 2001 to that in 2003?
Your answer should be compact. 0.81. What is the ratio of the Value added (current US$) in Estonia in 2001 to that in 2003?
Provide a succinct answer. 0.62. What is the ratio of the Value added (current US$) of Brunei Darussalam in 2002 to that in 2003?
Your answer should be very brief. 0.84. What is the ratio of the Value added (current US$) in Denmark in 2002 to that in 2003?
Offer a very short reply. 0.84. What is the ratio of the Value added (current US$) in Eritrea in 2002 to that in 2003?
Your answer should be compact. 0.82. What is the ratio of the Value added (current US$) of Estonia in 2002 to that in 2003?
Your response must be concise. 0.73. What is the difference between the highest and the second highest Value added (current US$) in Brunei Darussalam?
Provide a short and direct response. 3.85e+08. What is the difference between the highest and the second highest Value added (current US$) of Denmark?
Keep it short and to the point. 7.87e+09. What is the difference between the highest and the second highest Value added (current US$) in Eritrea?
Make the answer very short. 2.74e+07. What is the difference between the highest and the second highest Value added (current US$) in Estonia?
Ensure brevity in your answer.  6.99e+08. What is the difference between the highest and the lowest Value added (current US$) of Brunei Darussalam?
Your answer should be very brief. 2.12e+09. What is the difference between the highest and the lowest Value added (current US$) of Denmark?
Keep it short and to the point. 1.06e+1. What is the difference between the highest and the lowest Value added (current US$) in Eritrea?
Your response must be concise. 3.61e+07. What is the difference between the highest and the lowest Value added (current US$) of Estonia?
Offer a very short reply. 1.23e+09. 